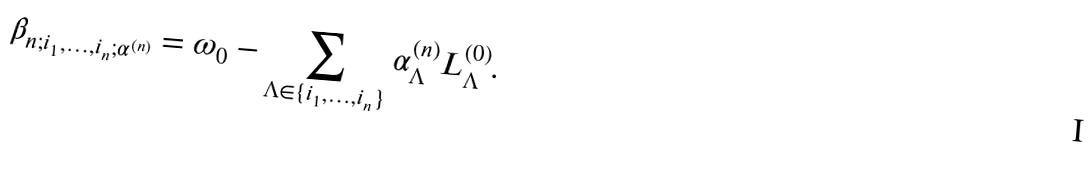<formula> <loc_0><loc_0><loc_500><loc_500>\beta _ { n ; i _ { 1 } , \dots , i _ { n } ; \alpha ^ { ( n ) } } = \omega _ { 0 } - \sum _ { \Lambda \in \{ i _ { 1 } , \dots , i _ { n } \} } \alpha ^ { ( n ) } _ { \Lambda } L _ { \Lambda } ^ { ( 0 ) } .</formula> 